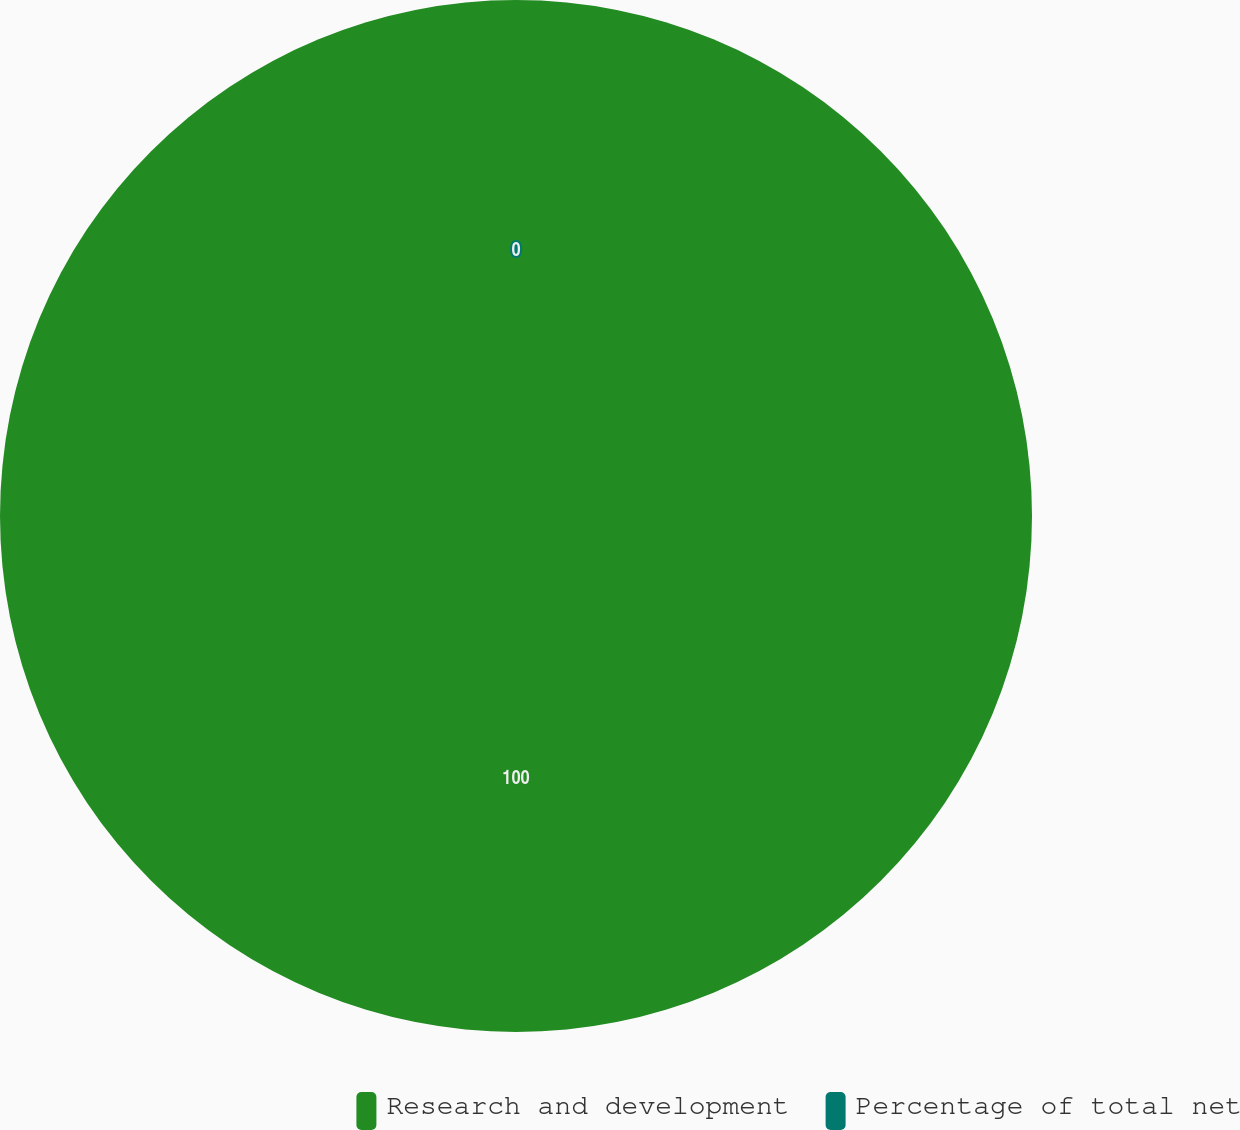Convert chart to OTSL. <chart><loc_0><loc_0><loc_500><loc_500><pie_chart><fcel>Research and development<fcel>Percentage of total net<nl><fcel>100.0%<fcel>0.0%<nl></chart> 